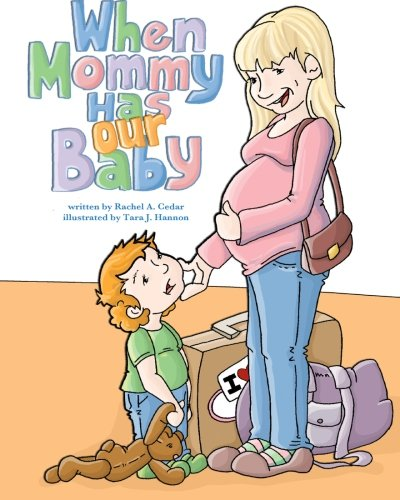What is the title of this book? The title of the book depicted in the image is 'When Mommy Has Our Baby.' 